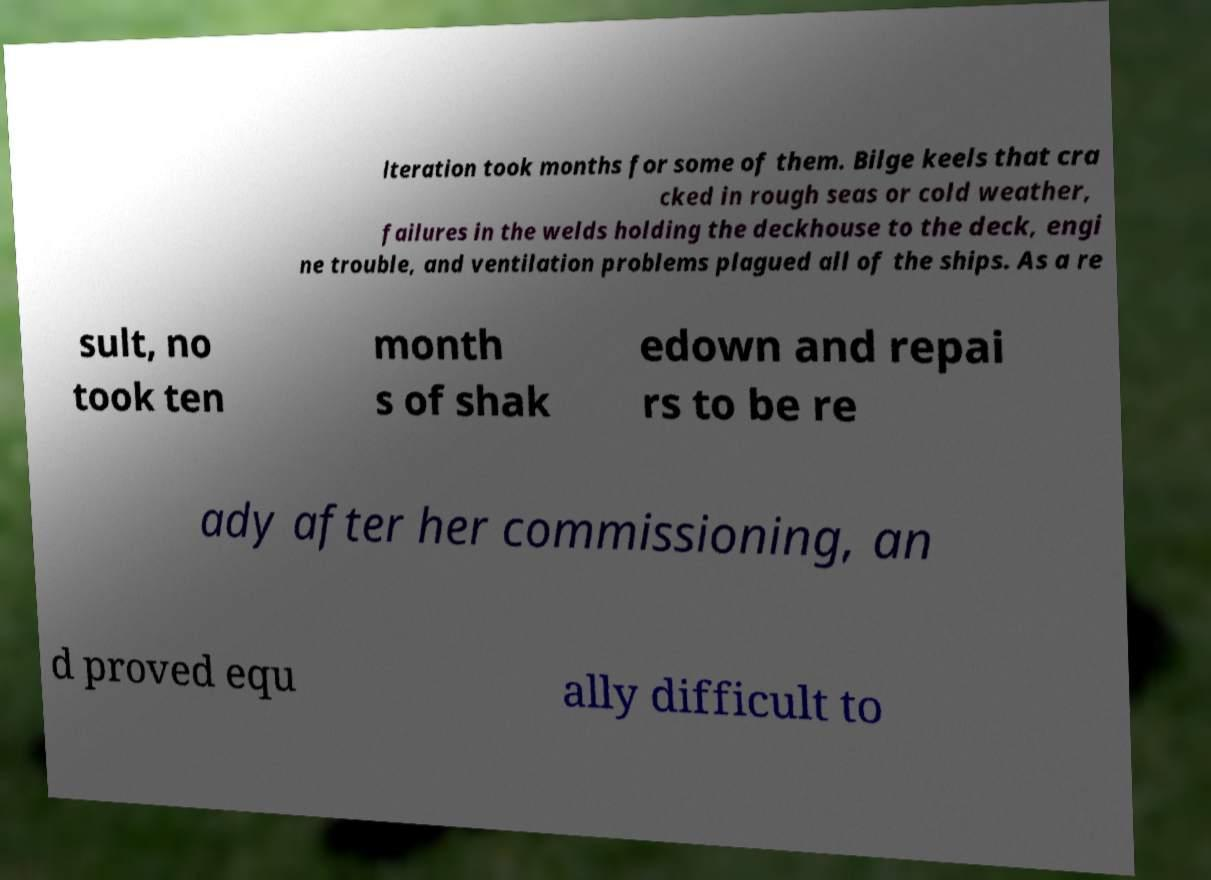Please read and relay the text visible in this image. What does it say? lteration took months for some of them. Bilge keels that cra cked in rough seas or cold weather, failures in the welds holding the deckhouse to the deck, engi ne trouble, and ventilation problems plagued all of the ships. As a re sult, no took ten month s of shak edown and repai rs to be re ady after her commissioning, an d proved equ ally difficult to 